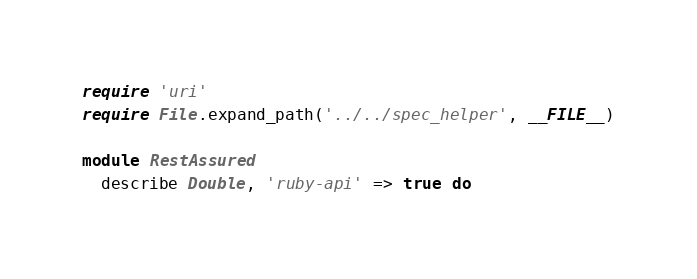Convert code to text. <code><loc_0><loc_0><loc_500><loc_500><_Ruby_>require 'uri'
require File.expand_path('../../spec_helper', __FILE__)

module RestAssured
  describe Double, 'ruby-api' => true do</code> 